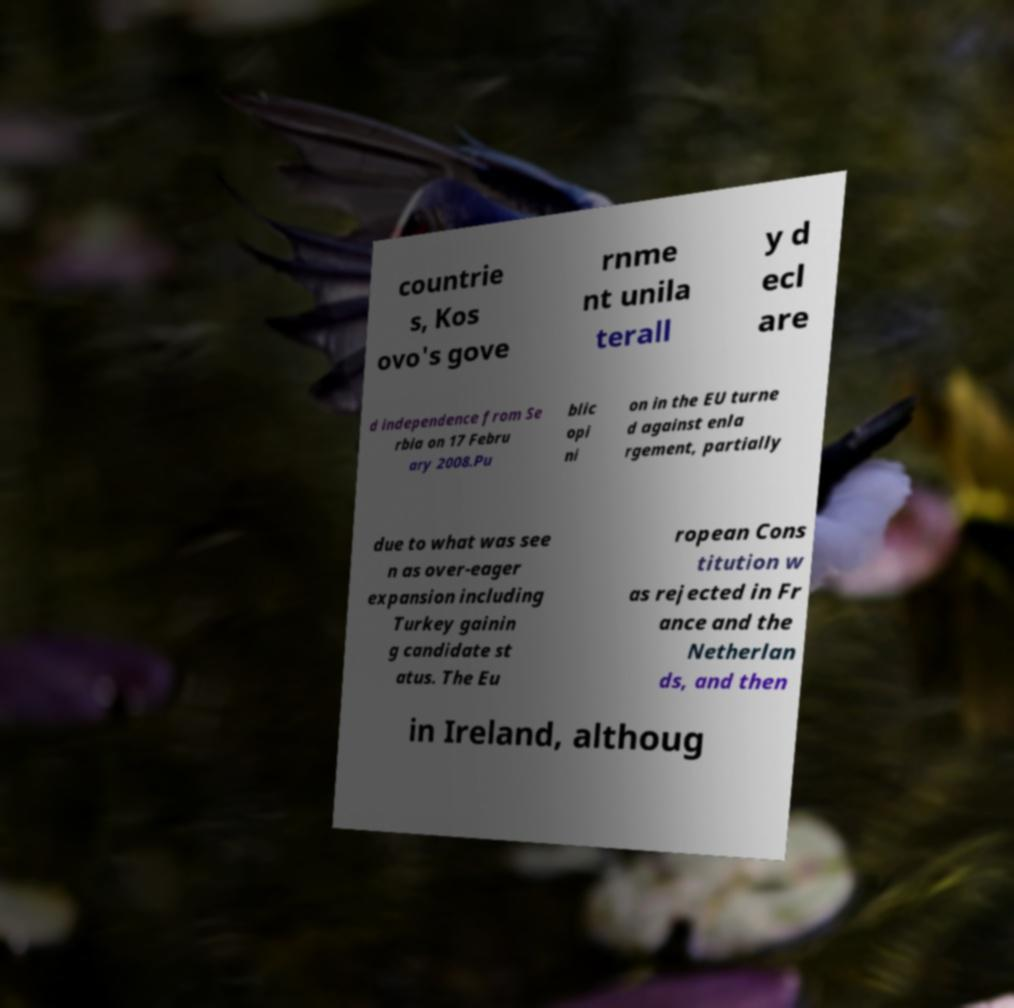I need the written content from this picture converted into text. Can you do that? countrie s, Kos ovo's gove rnme nt unila terall y d ecl are d independence from Se rbia on 17 Febru ary 2008.Pu blic opi ni on in the EU turne d against enla rgement, partially due to what was see n as over-eager expansion including Turkey gainin g candidate st atus. The Eu ropean Cons titution w as rejected in Fr ance and the Netherlan ds, and then in Ireland, althoug 